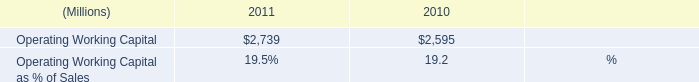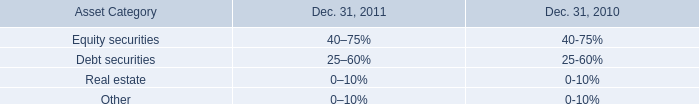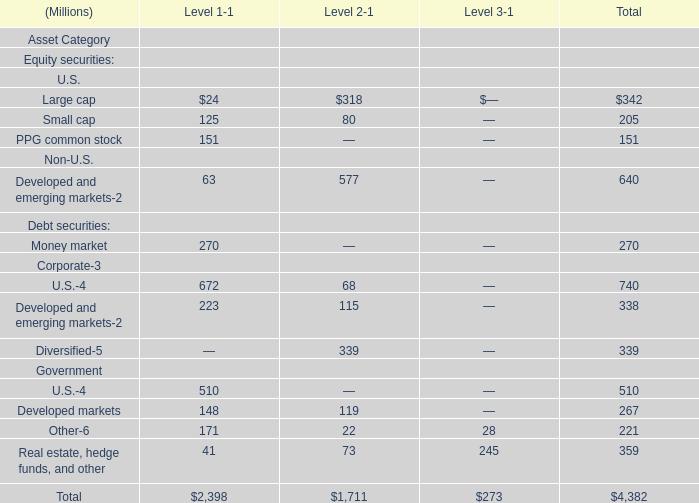what was the percentage change in cash from operating activities from 2009 to 2010? 
Computations: ((1310 - 1345) / 1345)
Answer: -0.02602. 